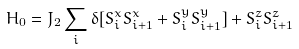<formula> <loc_0><loc_0><loc_500><loc_500>H _ { 0 } = J _ { 2 } \sum _ { i } \delta [ S ^ { x } _ { i } S ^ { x } _ { i + 1 } + S ^ { y } _ { i } S ^ { y } _ { i + 1 } ] + S ^ { z } _ { i } S ^ { z } _ { i + 1 }</formula> 